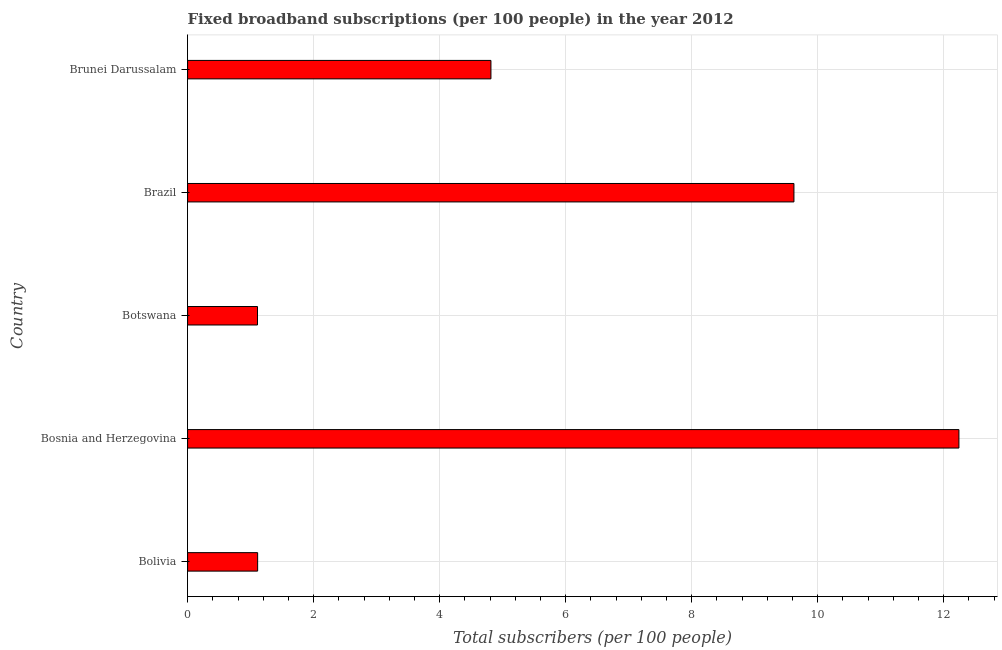Does the graph contain grids?
Make the answer very short. Yes. What is the title of the graph?
Ensure brevity in your answer.  Fixed broadband subscriptions (per 100 people) in the year 2012. What is the label or title of the X-axis?
Give a very brief answer. Total subscribers (per 100 people). What is the total number of fixed broadband subscriptions in Brazil?
Keep it short and to the point. 9.62. Across all countries, what is the maximum total number of fixed broadband subscriptions?
Offer a very short reply. 12.24. Across all countries, what is the minimum total number of fixed broadband subscriptions?
Ensure brevity in your answer.  1.11. In which country was the total number of fixed broadband subscriptions maximum?
Offer a terse response. Bosnia and Herzegovina. In which country was the total number of fixed broadband subscriptions minimum?
Provide a succinct answer. Botswana. What is the sum of the total number of fixed broadband subscriptions?
Keep it short and to the point. 28.9. What is the difference between the total number of fixed broadband subscriptions in Botswana and Brunei Darussalam?
Provide a short and direct response. -3.71. What is the average total number of fixed broadband subscriptions per country?
Offer a terse response. 5.78. What is the median total number of fixed broadband subscriptions?
Offer a very short reply. 4.81. In how many countries, is the total number of fixed broadband subscriptions greater than 2.4 ?
Provide a short and direct response. 3. What is the ratio of the total number of fixed broadband subscriptions in Botswana to that in Brazil?
Offer a very short reply. 0.12. Is the total number of fixed broadband subscriptions in Botswana less than that in Brazil?
Offer a very short reply. Yes. What is the difference between the highest and the second highest total number of fixed broadband subscriptions?
Ensure brevity in your answer.  2.62. What is the difference between the highest and the lowest total number of fixed broadband subscriptions?
Give a very brief answer. 11.13. Are all the bars in the graph horizontal?
Your response must be concise. Yes. What is the difference between two consecutive major ticks on the X-axis?
Offer a very short reply. 2. Are the values on the major ticks of X-axis written in scientific E-notation?
Provide a succinct answer. No. What is the Total subscribers (per 100 people) in Bolivia?
Offer a very short reply. 1.11. What is the Total subscribers (per 100 people) in Bosnia and Herzegovina?
Offer a very short reply. 12.24. What is the Total subscribers (per 100 people) of Botswana?
Your answer should be compact. 1.11. What is the Total subscribers (per 100 people) in Brazil?
Offer a terse response. 9.62. What is the Total subscribers (per 100 people) in Brunei Darussalam?
Your response must be concise. 4.81. What is the difference between the Total subscribers (per 100 people) in Bolivia and Bosnia and Herzegovina?
Keep it short and to the point. -11.13. What is the difference between the Total subscribers (per 100 people) in Bolivia and Botswana?
Offer a very short reply. 0. What is the difference between the Total subscribers (per 100 people) in Bolivia and Brazil?
Give a very brief answer. -8.51. What is the difference between the Total subscribers (per 100 people) in Bolivia and Brunei Darussalam?
Offer a terse response. -3.7. What is the difference between the Total subscribers (per 100 people) in Bosnia and Herzegovina and Botswana?
Keep it short and to the point. 11.13. What is the difference between the Total subscribers (per 100 people) in Bosnia and Herzegovina and Brazil?
Provide a succinct answer. 2.62. What is the difference between the Total subscribers (per 100 people) in Bosnia and Herzegovina and Brunei Darussalam?
Provide a succinct answer. 7.43. What is the difference between the Total subscribers (per 100 people) in Botswana and Brazil?
Provide a succinct answer. -8.51. What is the difference between the Total subscribers (per 100 people) in Botswana and Brunei Darussalam?
Offer a terse response. -3.71. What is the difference between the Total subscribers (per 100 people) in Brazil and Brunei Darussalam?
Your answer should be compact. 4.81. What is the ratio of the Total subscribers (per 100 people) in Bolivia to that in Bosnia and Herzegovina?
Offer a terse response. 0.09. What is the ratio of the Total subscribers (per 100 people) in Bolivia to that in Botswana?
Provide a short and direct response. 1. What is the ratio of the Total subscribers (per 100 people) in Bolivia to that in Brazil?
Offer a terse response. 0.12. What is the ratio of the Total subscribers (per 100 people) in Bolivia to that in Brunei Darussalam?
Offer a very short reply. 0.23. What is the ratio of the Total subscribers (per 100 people) in Bosnia and Herzegovina to that in Botswana?
Ensure brevity in your answer.  11.03. What is the ratio of the Total subscribers (per 100 people) in Bosnia and Herzegovina to that in Brazil?
Your response must be concise. 1.27. What is the ratio of the Total subscribers (per 100 people) in Bosnia and Herzegovina to that in Brunei Darussalam?
Your response must be concise. 2.54. What is the ratio of the Total subscribers (per 100 people) in Botswana to that in Brazil?
Ensure brevity in your answer.  0.12. What is the ratio of the Total subscribers (per 100 people) in Botswana to that in Brunei Darussalam?
Provide a short and direct response. 0.23. What is the ratio of the Total subscribers (per 100 people) in Brazil to that in Brunei Darussalam?
Your response must be concise. 2. 